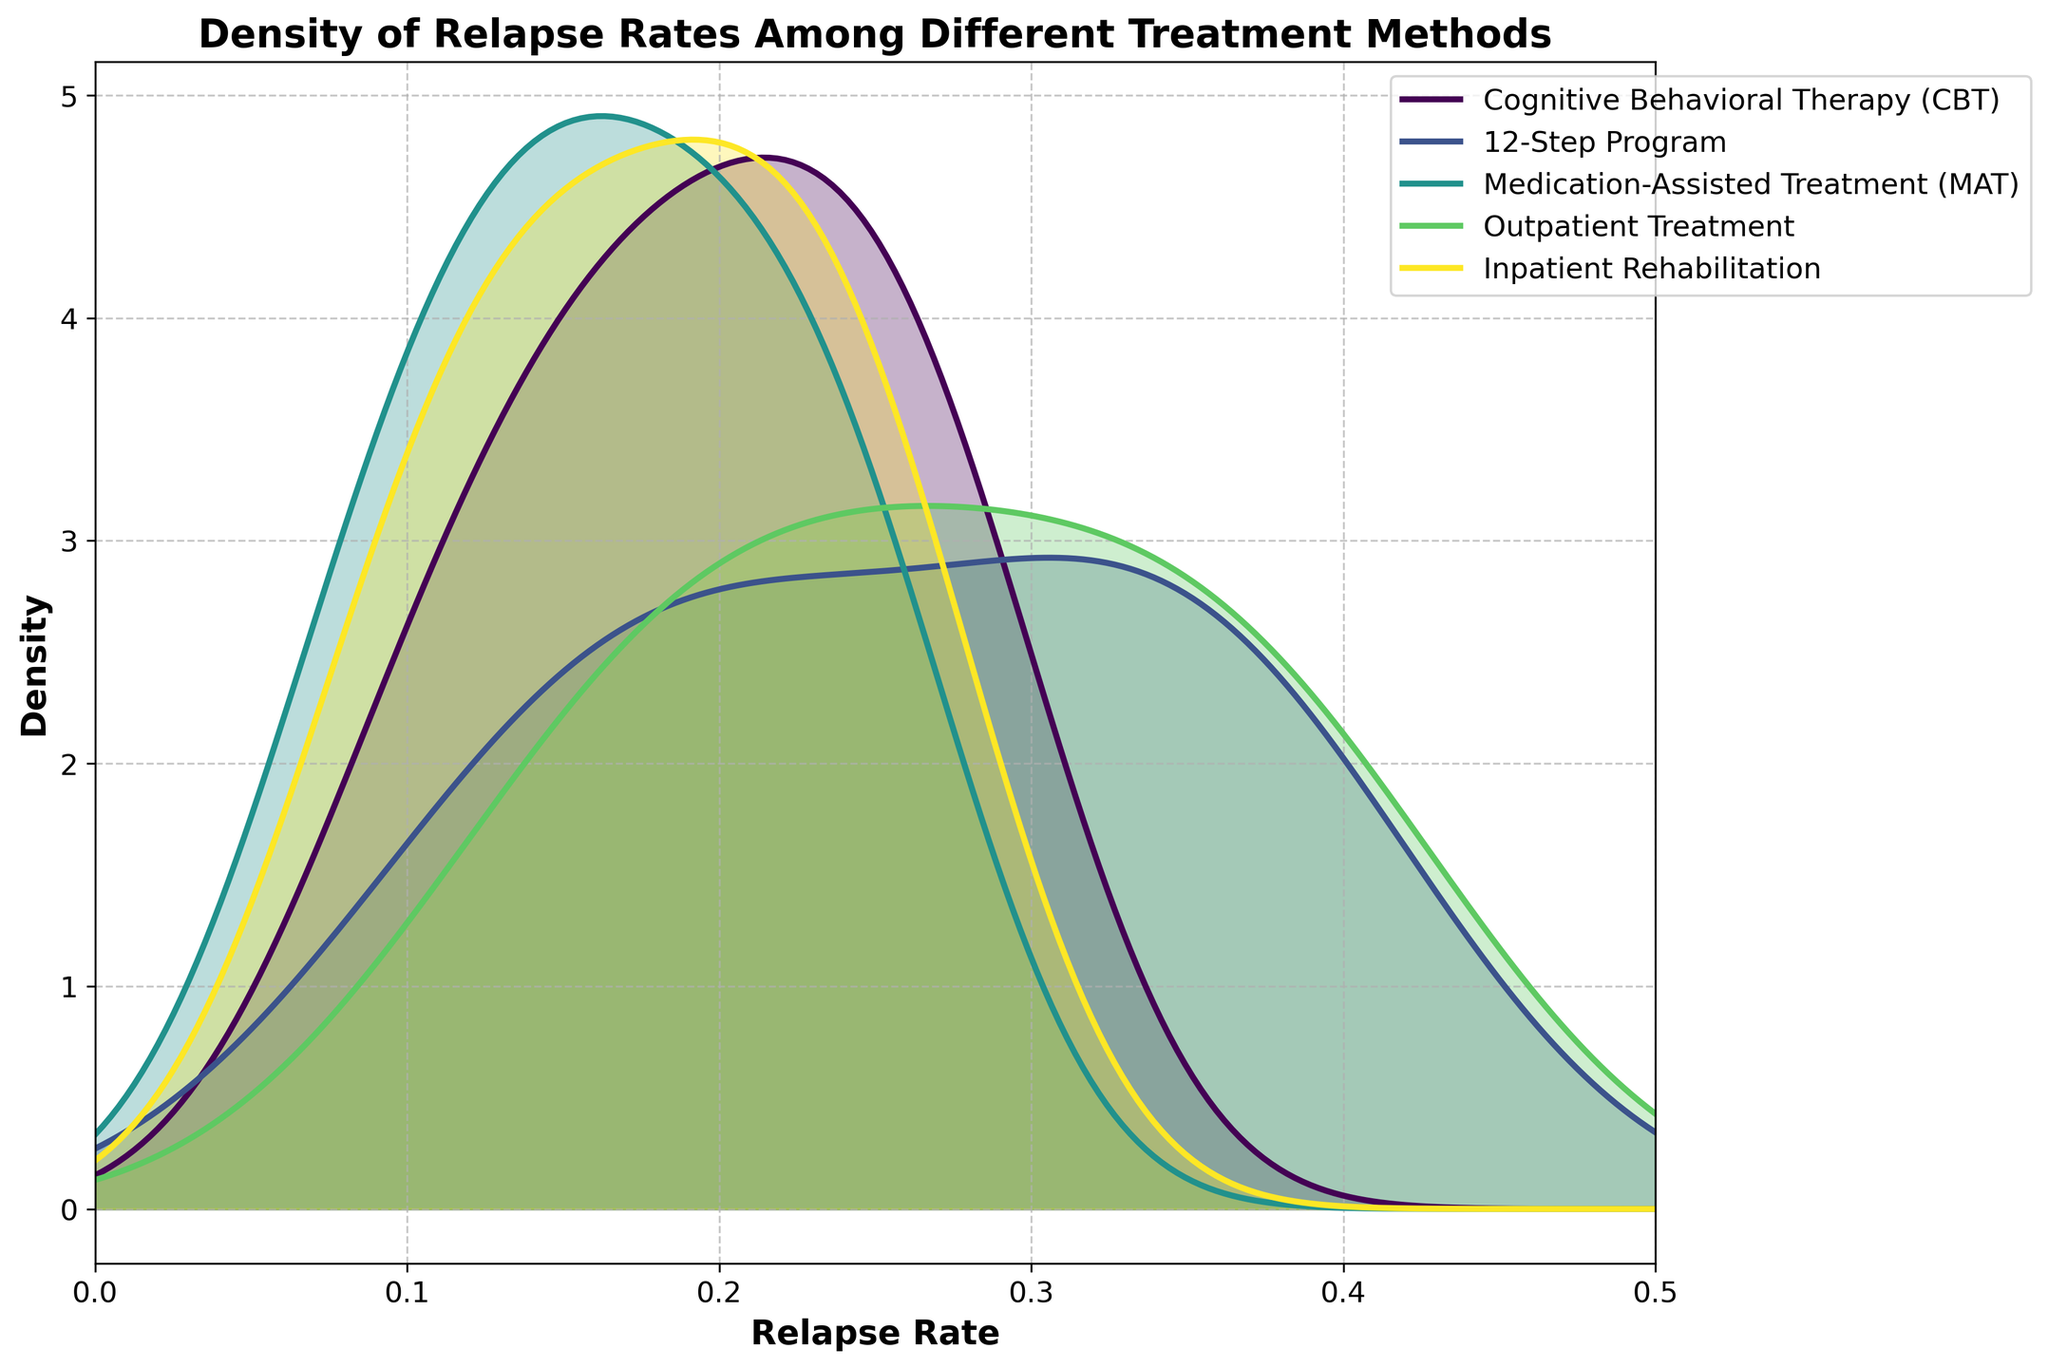Which treatment method has the highest density peak? By examining the plot, identify which treatment curve reaches the highest value on the Y-axis. The peak of the curve represents the highest density of relapse rates for that treatment.
Answer: Outpatient Treatment Which treatment methods have similar relapse rate density curves? Compare the shapes of the density curves to determine which ones follow a similar pattern. Look for treatments whose curves rise and fall at roughly the same points.
Answer: CBT and Inpatient Rehabilitation What is the approximate relapse rate where the density of the 12-Step Program is highest? Find the peak of the density curve for the 12-Step Program on the X-axis. This point signifies the relapse rate with the highest density for this program.
Answer: Around 0.36 Which treatment method shows the widest spread of relapse rates? The treatment with the widest curve spread on the X-axis indicates the widest range of relapse rates. Compare the widths of the curves to identify this.
Answer: Outpatient Treatment How do the density peaks of Medication-Assisted Treatment (MAT) and Inpatient Rehabilitation compare? Look at the heights of the peaks for both MAT and Inpatient Rehabilitation on the Y-axis to determine how they compare in density.
Answer: MAT has a slightly lower peak than Inpatient Rehabilitation Between CBT and the 12-Step Program, which treatment has lower relapse rates at higher densities? Examine the positions and heights of the density peaks for CBT and the 12-Step Program to determine which treatment has lower relapse rates at its highest density point.
Answer: CBT At a relapse rate of 0.25, which treatment method shows the highest density? Identify where the relapse rate of 0.25 falls on the X-axis and compare the Y-axis values (densities) of the different treatment curves at this point.
Answer: Medication-Assisted Treatment (MAT) Is there a treatment method with minimal overlap in relapse rate densities with others? Look for a treatment density curve that does not significantly overlap with the others across the X-axis. This signifies minimal overlap in relapse rates.
Answer: Outpatient Treatment What can be inferred about the effectiveness of CBT compared to the 12-Step Program based on their density plots? Compare the density curves of CBT and the 12-Step Program. Higher density at lower relapse rates suggests better effectiveness.
Answer: CBT appears more effective 